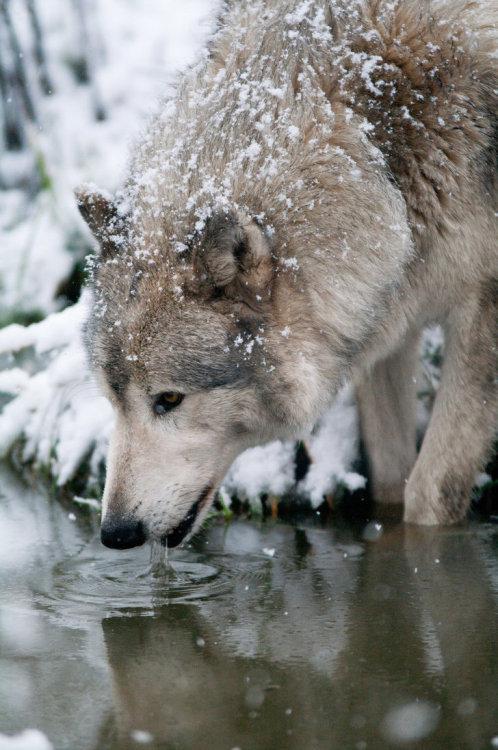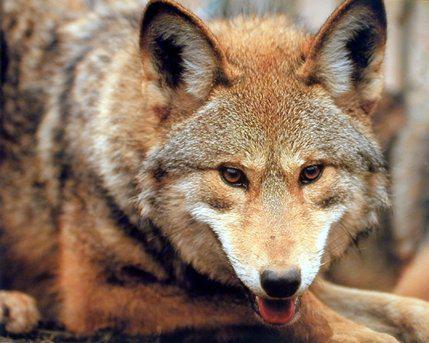The first image is the image on the left, the second image is the image on the right. Analyze the images presented: Is the assertion "The wild dog in one of the images is lying down." valid? Answer yes or no. Yes. The first image is the image on the left, the second image is the image on the right. Evaluate the accuracy of this statement regarding the images: "An image shows a wolf with a dusting of snow on its fur.". Is it true? Answer yes or no. Yes. 